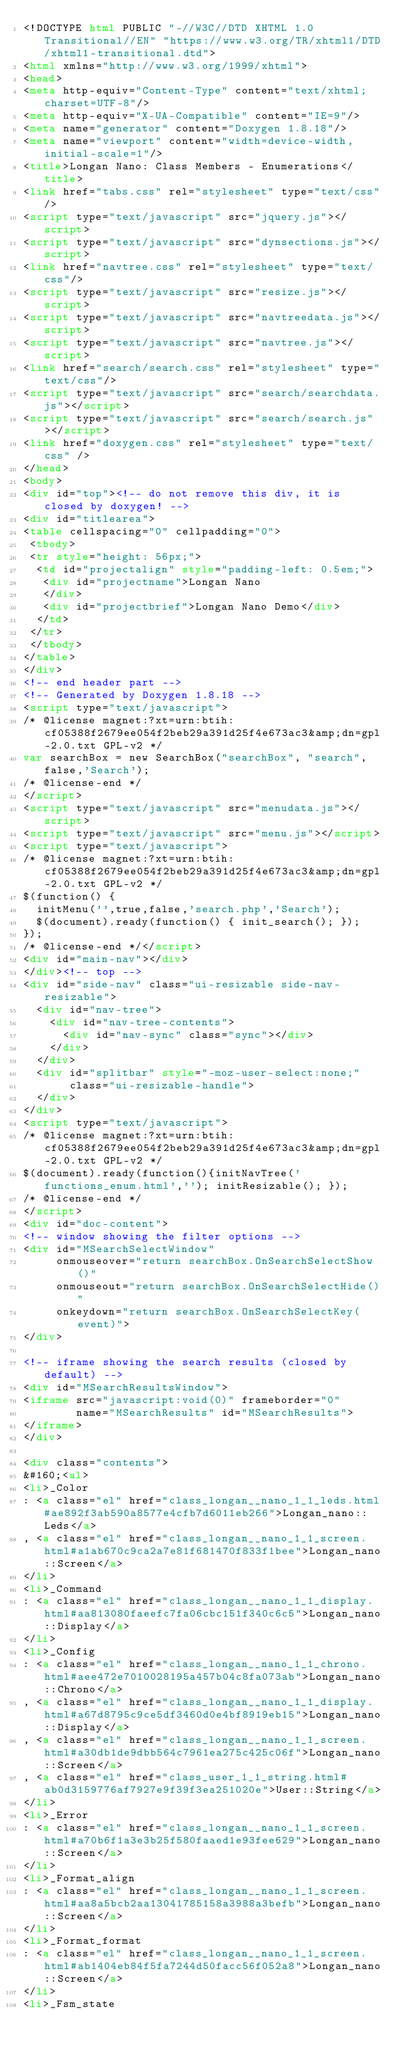<code> <loc_0><loc_0><loc_500><loc_500><_HTML_><!DOCTYPE html PUBLIC "-//W3C//DTD XHTML 1.0 Transitional//EN" "https://www.w3.org/TR/xhtml1/DTD/xhtml1-transitional.dtd">
<html xmlns="http://www.w3.org/1999/xhtml">
<head>
<meta http-equiv="Content-Type" content="text/xhtml;charset=UTF-8"/>
<meta http-equiv="X-UA-Compatible" content="IE=9"/>
<meta name="generator" content="Doxygen 1.8.18"/>
<meta name="viewport" content="width=device-width, initial-scale=1"/>
<title>Longan Nano: Class Members - Enumerations</title>
<link href="tabs.css" rel="stylesheet" type="text/css"/>
<script type="text/javascript" src="jquery.js"></script>
<script type="text/javascript" src="dynsections.js"></script>
<link href="navtree.css" rel="stylesheet" type="text/css"/>
<script type="text/javascript" src="resize.js"></script>
<script type="text/javascript" src="navtreedata.js"></script>
<script type="text/javascript" src="navtree.js"></script>
<link href="search/search.css" rel="stylesheet" type="text/css"/>
<script type="text/javascript" src="search/searchdata.js"></script>
<script type="text/javascript" src="search/search.js"></script>
<link href="doxygen.css" rel="stylesheet" type="text/css" />
</head>
<body>
<div id="top"><!-- do not remove this div, it is closed by doxygen! -->
<div id="titlearea">
<table cellspacing="0" cellpadding="0">
 <tbody>
 <tr style="height: 56px;">
  <td id="projectalign" style="padding-left: 0.5em;">
   <div id="projectname">Longan Nano
   </div>
   <div id="projectbrief">Longan Nano Demo</div>
  </td>
 </tr>
 </tbody>
</table>
</div>
<!-- end header part -->
<!-- Generated by Doxygen 1.8.18 -->
<script type="text/javascript">
/* @license magnet:?xt=urn:btih:cf05388f2679ee054f2beb29a391d25f4e673ac3&amp;dn=gpl-2.0.txt GPL-v2 */
var searchBox = new SearchBox("searchBox", "search",false,'Search');
/* @license-end */
</script>
<script type="text/javascript" src="menudata.js"></script>
<script type="text/javascript" src="menu.js"></script>
<script type="text/javascript">
/* @license magnet:?xt=urn:btih:cf05388f2679ee054f2beb29a391d25f4e673ac3&amp;dn=gpl-2.0.txt GPL-v2 */
$(function() {
  initMenu('',true,false,'search.php','Search');
  $(document).ready(function() { init_search(); });
});
/* @license-end */</script>
<div id="main-nav"></div>
</div><!-- top -->
<div id="side-nav" class="ui-resizable side-nav-resizable">
  <div id="nav-tree">
    <div id="nav-tree-contents">
      <div id="nav-sync" class="sync"></div>
    </div>
  </div>
  <div id="splitbar" style="-moz-user-select:none;" 
       class="ui-resizable-handle">
  </div>
</div>
<script type="text/javascript">
/* @license magnet:?xt=urn:btih:cf05388f2679ee054f2beb29a391d25f4e673ac3&amp;dn=gpl-2.0.txt GPL-v2 */
$(document).ready(function(){initNavTree('functions_enum.html',''); initResizable(); });
/* @license-end */
</script>
<div id="doc-content">
<!-- window showing the filter options -->
<div id="MSearchSelectWindow"
     onmouseover="return searchBox.OnSearchSelectShow()"
     onmouseout="return searchBox.OnSearchSelectHide()"
     onkeydown="return searchBox.OnSearchSelectKey(event)">
</div>

<!-- iframe showing the search results (closed by default) -->
<div id="MSearchResultsWindow">
<iframe src="javascript:void(0)" frameborder="0" 
        name="MSearchResults" id="MSearchResults">
</iframe>
</div>

<div class="contents">
&#160;<ul>
<li>_Color
: <a class="el" href="class_longan__nano_1_1_leds.html#ae892f3ab590a8577e4cfb7d6011eb266">Longan_nano::Leds</a>
, <a class="el" href="class_longan__nano_1_1_screen.html#a1ab670c9ca2a7e81f681470f833f1bee">Longan_nano::Screen</a>
</li>
<li>_Command
: <a class="el" href="class_longan__nano_1_1_display.html#aa813080faeefc7fa06cbc151f340c6c5">Longan_nano::Display</a>
</li>
<li>_Config
: <a class="el" href="class_longan__nano_1_1_chrono.html#aee472e7010028195a457b04c8fa073ab">Longan_nano::Chrono</a>
, <a class="el" href="class_longan__nano_1_1_display.html#a67d8795c9ce5df3460d0e4bf8919eb15">Longan_nano::Display</a>
, <a class="el" href="class_longan__nano_1_1_screen.html#a30db1de9dbb564c7961ea275c425c06f">Longan_nano::Screen</a>
, <a class="el" href="class_user_1_1_string.html#ab0d3159776af7927e9f39f3ea251020e">User::String</a>
</li>
<li>_Error
: <a class="el" href="class_longan__nano_1_1_screen.html#a70b6f1a3e3b25f580faaed1e93fee629">Longan_nano::Screen</a>
</li>
<li>_Format_align
: <a class="el" href="class_longan__nano_1_1_screen.html#aa8a5bcb2aa13041785158a3988a3befb">Longan_nano::Screen</a>
</li>
<li>_Format_format
: <a class="el" href="class_longan__nano_1_1_screen.html#ab1404eb84f5fa7244d50facc56f052a8">Longan_nano::Screen</a>
</li>
<li>_Fsm_state</code> 